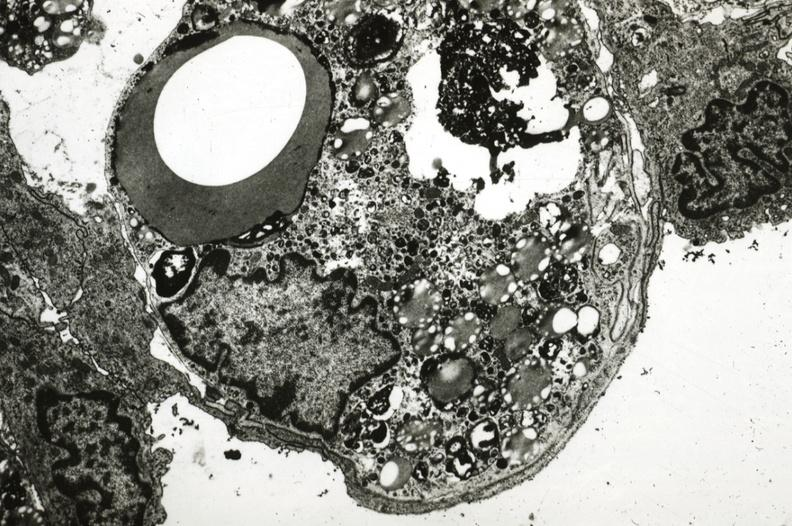where is this?
Answer the question using a single word or phrase. Aorta 